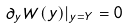Convert formula to latex. <formula><loc_0><loc_0><loc_500><loc_500>\partial _ { y } W ( y ) | _ { y = Y } = 0</formula> 